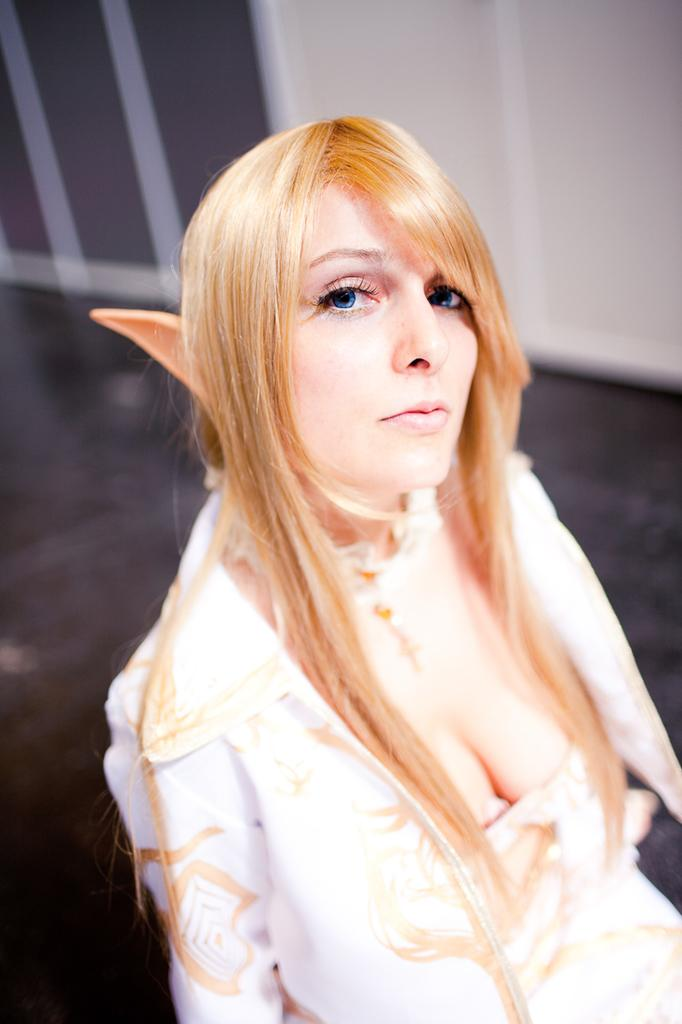Who is present in the image? There is a lady in the image. What can be seen in the background of the image? There is a wall in the background of the image. What type of furniture is being assembled by the lady in the image? There is no furniture present in the image, nor is the lady assembling anything. 